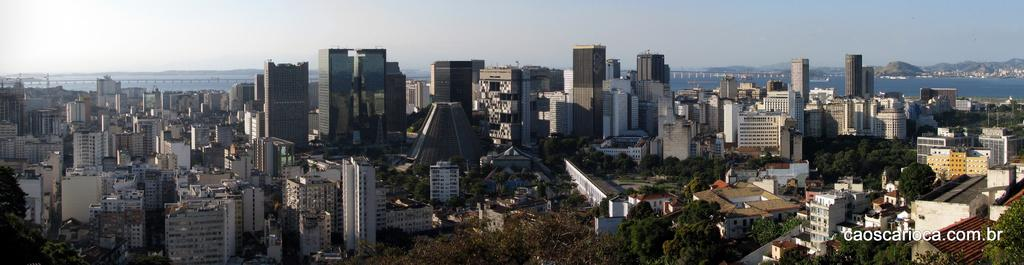What type of structures can be seen in the image? There are buildings in the image. What natural elements are present in the image? There are trees, water, and hills visible in the image. What man-made structure connects the two sides of the water? There is a bridge in the image. What part of the sky is visible in the image? The sky is visible in the image. What objects can be seen in the image? There are objects in the image, but their specific details are not mentioned in the facts. Is there any text or marking on the image? Yes, there is a watermark at the bottom right side of the image. What year is depicted in the image? The year is not mentioned or depicted in the image. Can you tell me how many people are playing in the image? There is no indication of people playing in the image; it features buildings, trees, water, hills, a bridge, the sky, objects, and a watermark. 